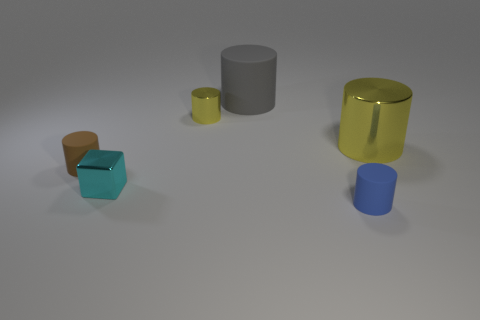How many yellow cylinders must be subtracted to get 1 yellow cylinders? 1 Subtract all tiny cylinders. How many cylinders are left? 2 Subtract all brown cylinders. How many cylinders are left? 4 Add 3 big brown blocks. How many objects exist? 9 Subtract 0 purple spheres. How many objects are left? 6 Subtract all cylinders. How many objects are left? 1 Subtract 1 blocks. How many blocks are left? 0 Subtract all yellow cylinders. Subtract all yellow blocks. How many cylinders are left? 3 Subtract all cyan blocks. How many brown cylinders are left? 1 Subtract all big things. Subtract all large metallic things. How many objects are left? 3 